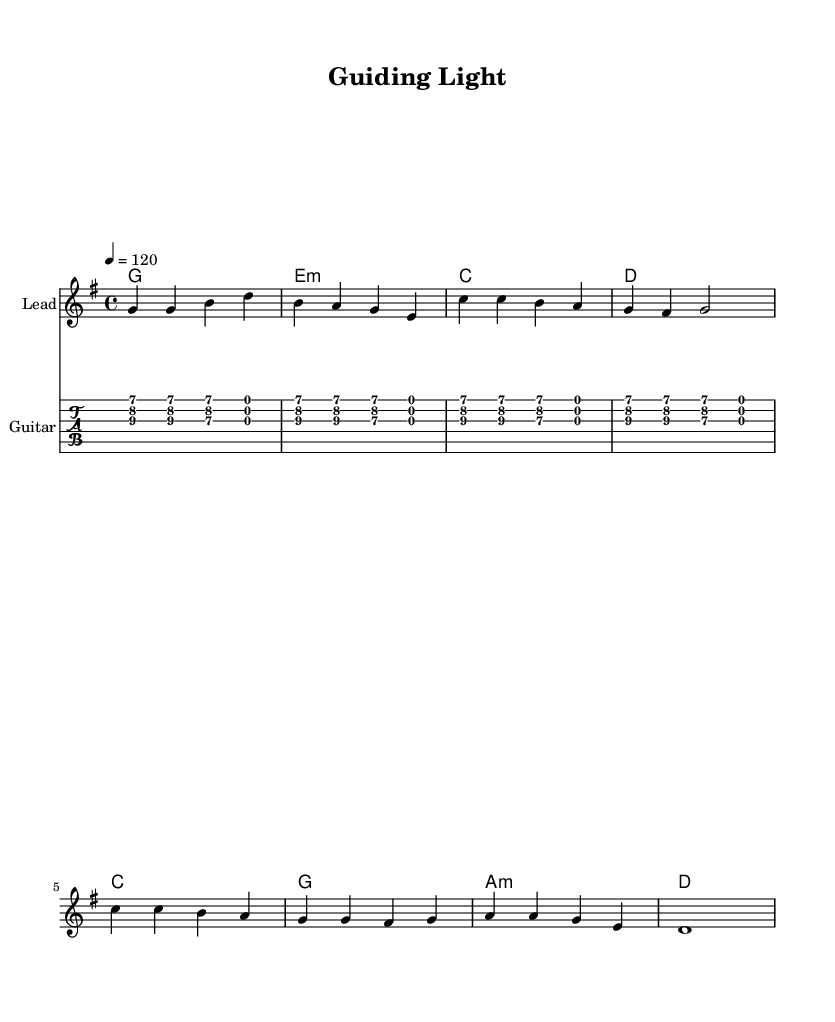What is the key signature of this music? The key signature is G major, which has one sharp (F#). This can be identified by looking at the beginning of the staff where the sharp is placed.
Answer: G major What is the time signature of the piece? The time signature is 4/4, which indicates that there are four beats in each measure, and the quarter note gets one beat. This can be seen at the beginning of the score where the time signature is indicated.
Answer: 4/4 What is the tempo marking for this piece? The tempo marking is 120, which means there are 120 beats per minute. This is indicated by the tempo marking above the staff.
Answer: 120 How many measures are in the verse section? The verse section contains four measures. By counting the groups of notes separated by vertical lines (measure bars) in the melody, we determine the number of measures.
Answer: Four What is the primary theme expressed in the lyrics? The primary theme is mentorship. The lyrics explicitly discuss watching and learning from a mentor, highlighting the guidance provided. This theme is repeated throughout the verses and chorus.
Answer: Mentorship Which chord follows the second measure of the verse? The chord following the second measure of the verse is E minor. This can be verified by examining the chord names written below the melody where the progression is indicated.
Answer: E minor What type of guitar technique is indicated by the notation? The guitar technique used is a riff. Riffs typically consist of short repeated musical phrases, and this is a characteristic element in rock music found in the notation for the guitar part.
Answer: Riff 